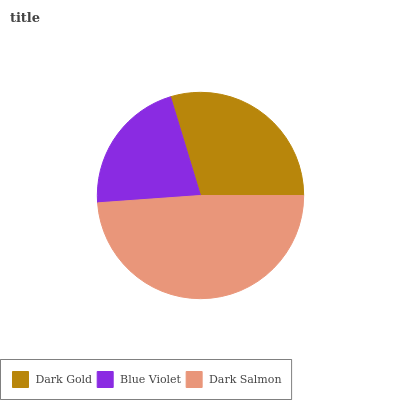Is Blue Violet the minimum?
Answer yes or no. Yes. Is Dark Salmon the maximum?
Answer yes or no. Yes. Is Dark Salmon the minimum?
Answer yes or no. No. Is Blue Violet the maximum?
Answer yes or no. No. Is Dark Salmon greater than Blue Violet?
Answer yes or no. Yes. Is Blue Violet less than Dark Salmon?
Answer yes or no. Yes. Is Blue Violet greater than Dark Salmon?
Answer yes or no. No. Is Dark Salmon less than Blue Violet?
Answer yes or no. No. Is Dark Gold the high median?
Answer yes or no. Yes. Is Dark Gold the low median?
Answer yes or no. Yes. Is Dark Salmon the high median?
Answer yes or no. No. Is Dark Salmon the low median?
Answer yes or no. No. 